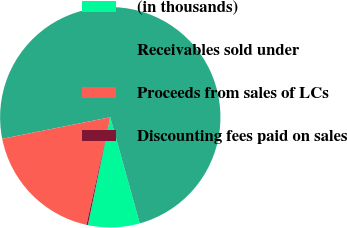Convert chart to OTSL. <chart><loc_0><loc_0><loc_500><loc_500><pie_chart><fcel>(in thousands)<fcel>Receivables sold under<fcel>Proceeds from sales of LCs<fcel>Discounting fees paid on sales<nl><fcel>7.57%<fcel>73.82%<fcel>18.4%<fcel>0.21%<nl></chart> 